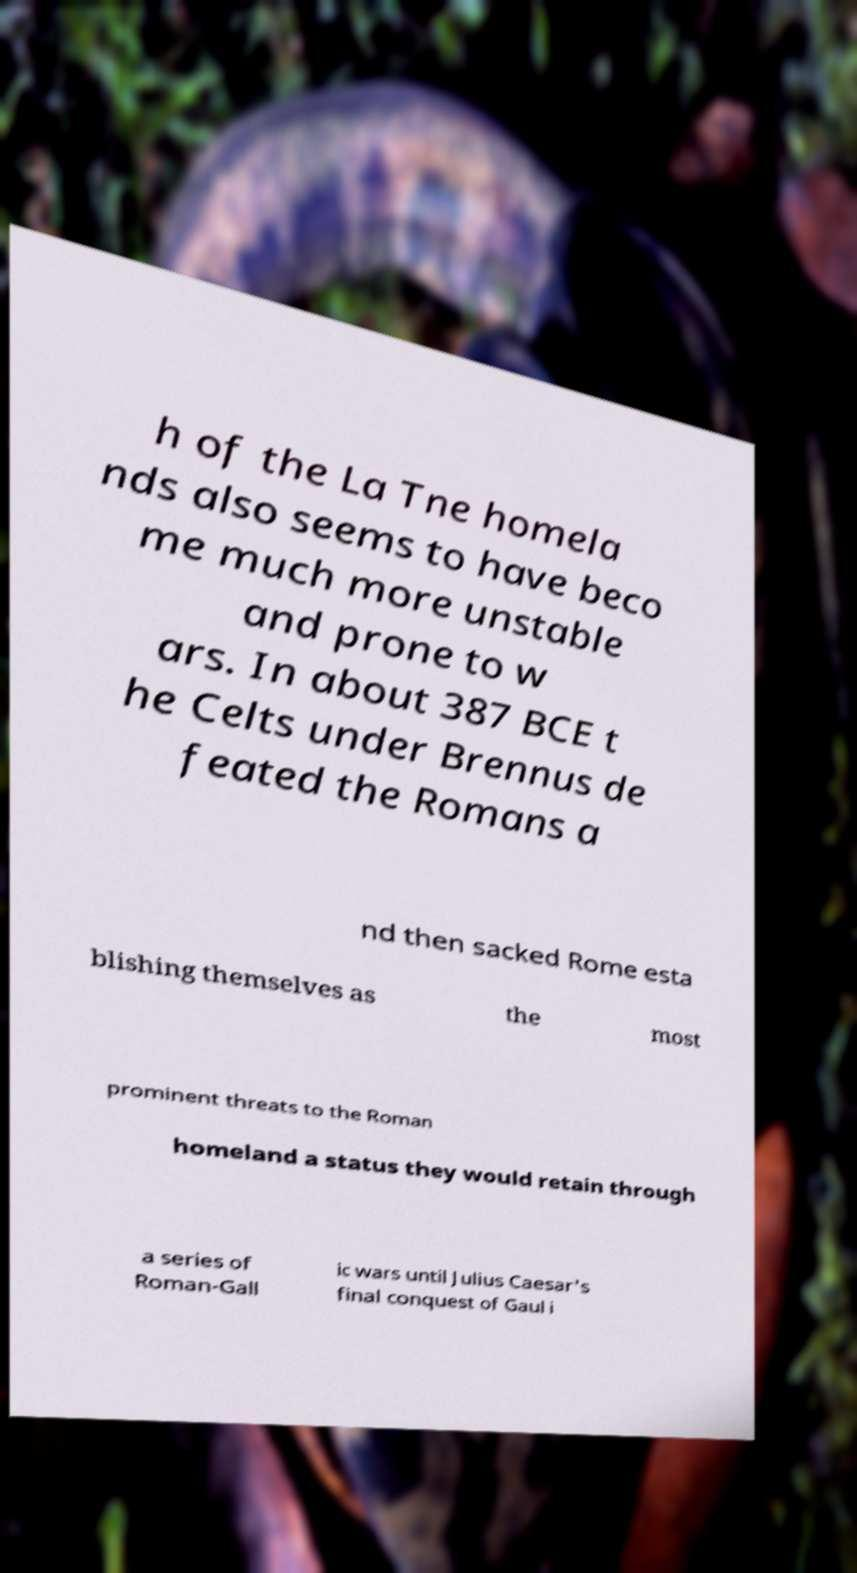What messages or text are displayed in this image? I need them in a readable, typed format. h of the La Tne homela nds also seems to have beco me much more unstable and prone to w ars. In about 387 BCE t he Celts under Brennus de feated the Romans a nd then sacked Rome esta blishing themselves as the most prominent threats to the Roman homeland a status they would retain through a series of Roman-Gall ic wars until Julius Caesar's final conquest of Gaul i 